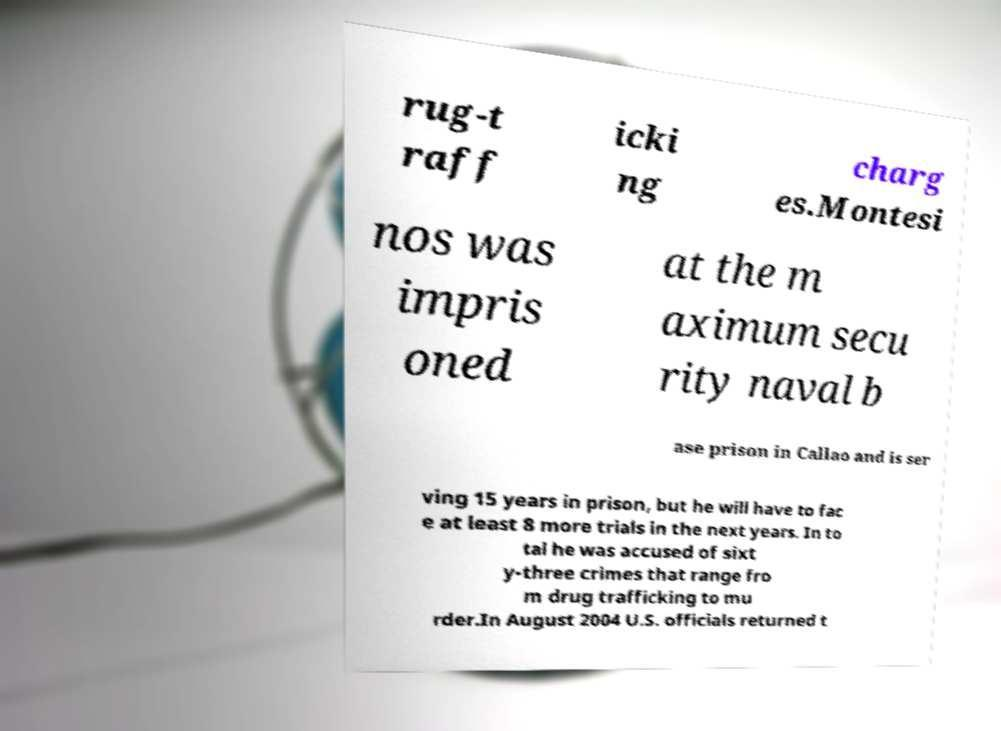Can you accurately transcribe the text from the provided image for me? rug-t raff icki ng charg es.Montesi nos was impris oned at the m aximum secu rity naval b ase prison in Callao and is ser ving 15 years in prison, but he will have to fac e at least 8 more trials in the next years. In to tal he was accused of sixt y-three crimes that range fro m drug trafficking to mu rder.In August 2004 U.S. officials returned t 